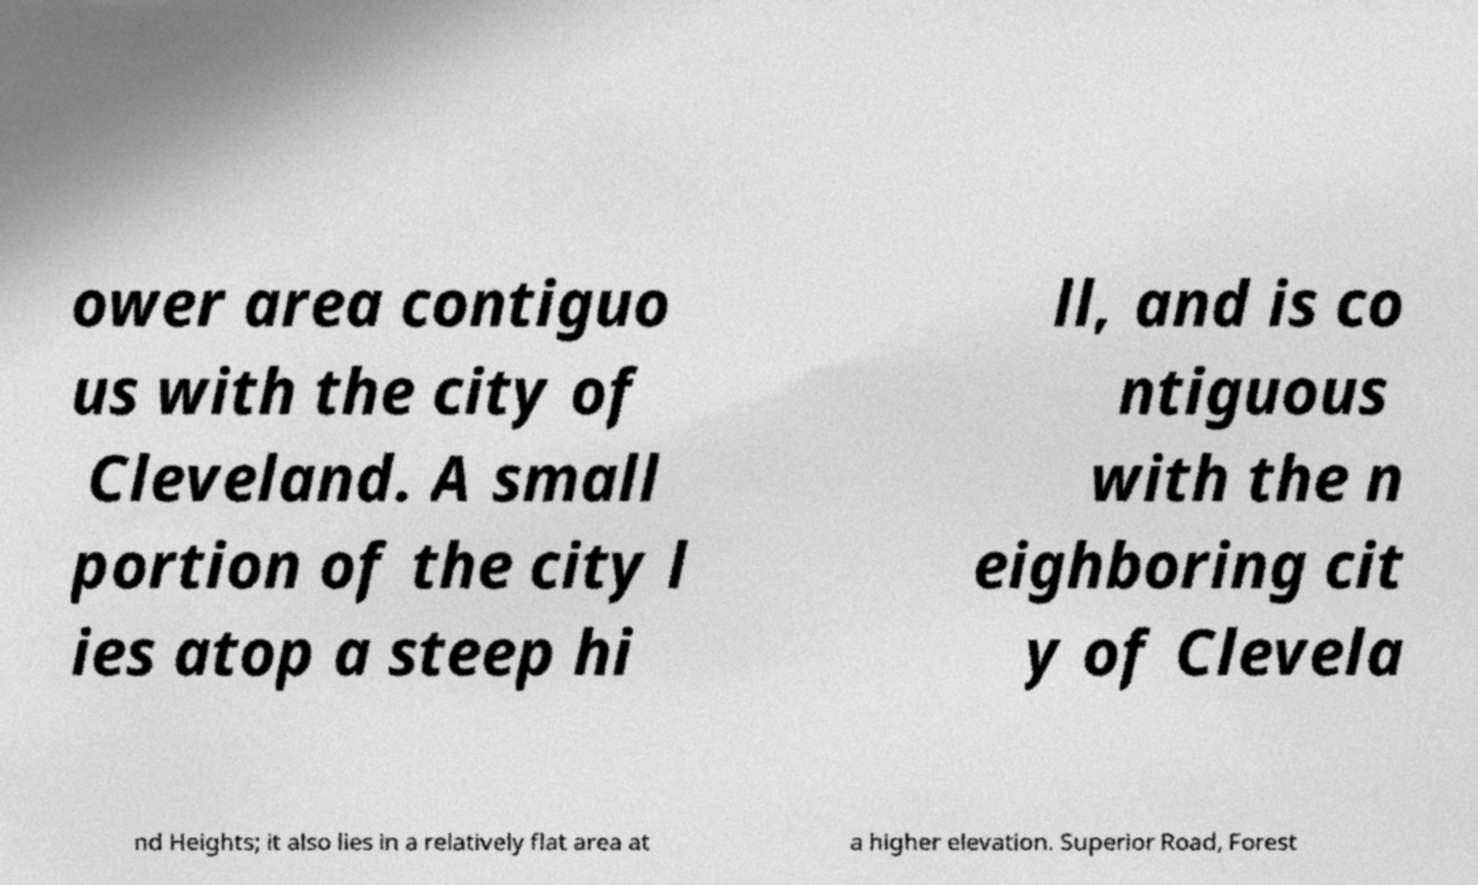Could you extract and type out the text from this image? ower area contiguo us with the city of Cleveland. A small portion of the city l ies atop a steep hi ll, and is co ntiguous with the n eighboring cit y of Clevela nd Heights; it also lies in a relatively flat area at a higher elevation. Superior Road, Forest 